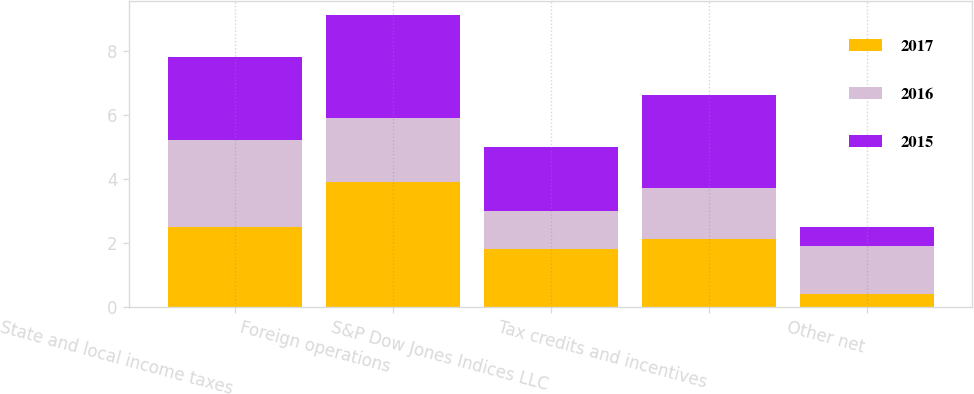Convert chart to OTSL. <chart><loc_0><loc_0><loc_500><loc_500><stacked_bar_chart><ecel><fcel>State and local income taxes<fcel>Foreign operations<fcel>S&P Dow Jones Indices LLC<fcel>Tax credits and incentives<fcel>Other net<nl><fcel>2017<fcel>2.5<fcel>3.9<fcel>1.8<fcel>2.1<fcel>0.4<nl><fcel>2016<fcel>2.7<fcel>2<fcel>1.2<fcel>1.6<fcel>1.5<nl><fcel>2015<fcel>2.6<fcel>3.2<fcel>2<fcel>2.9<fcel>0.6<nl></chart> 